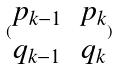<formula> <loc_0><loc_0><loc_500><loc_500>( \begin{matrix} p _ { k - 1 } & p _ { k } \\ q _ { k - 1 } & q _ { k } \end{matrix} )</formula> 